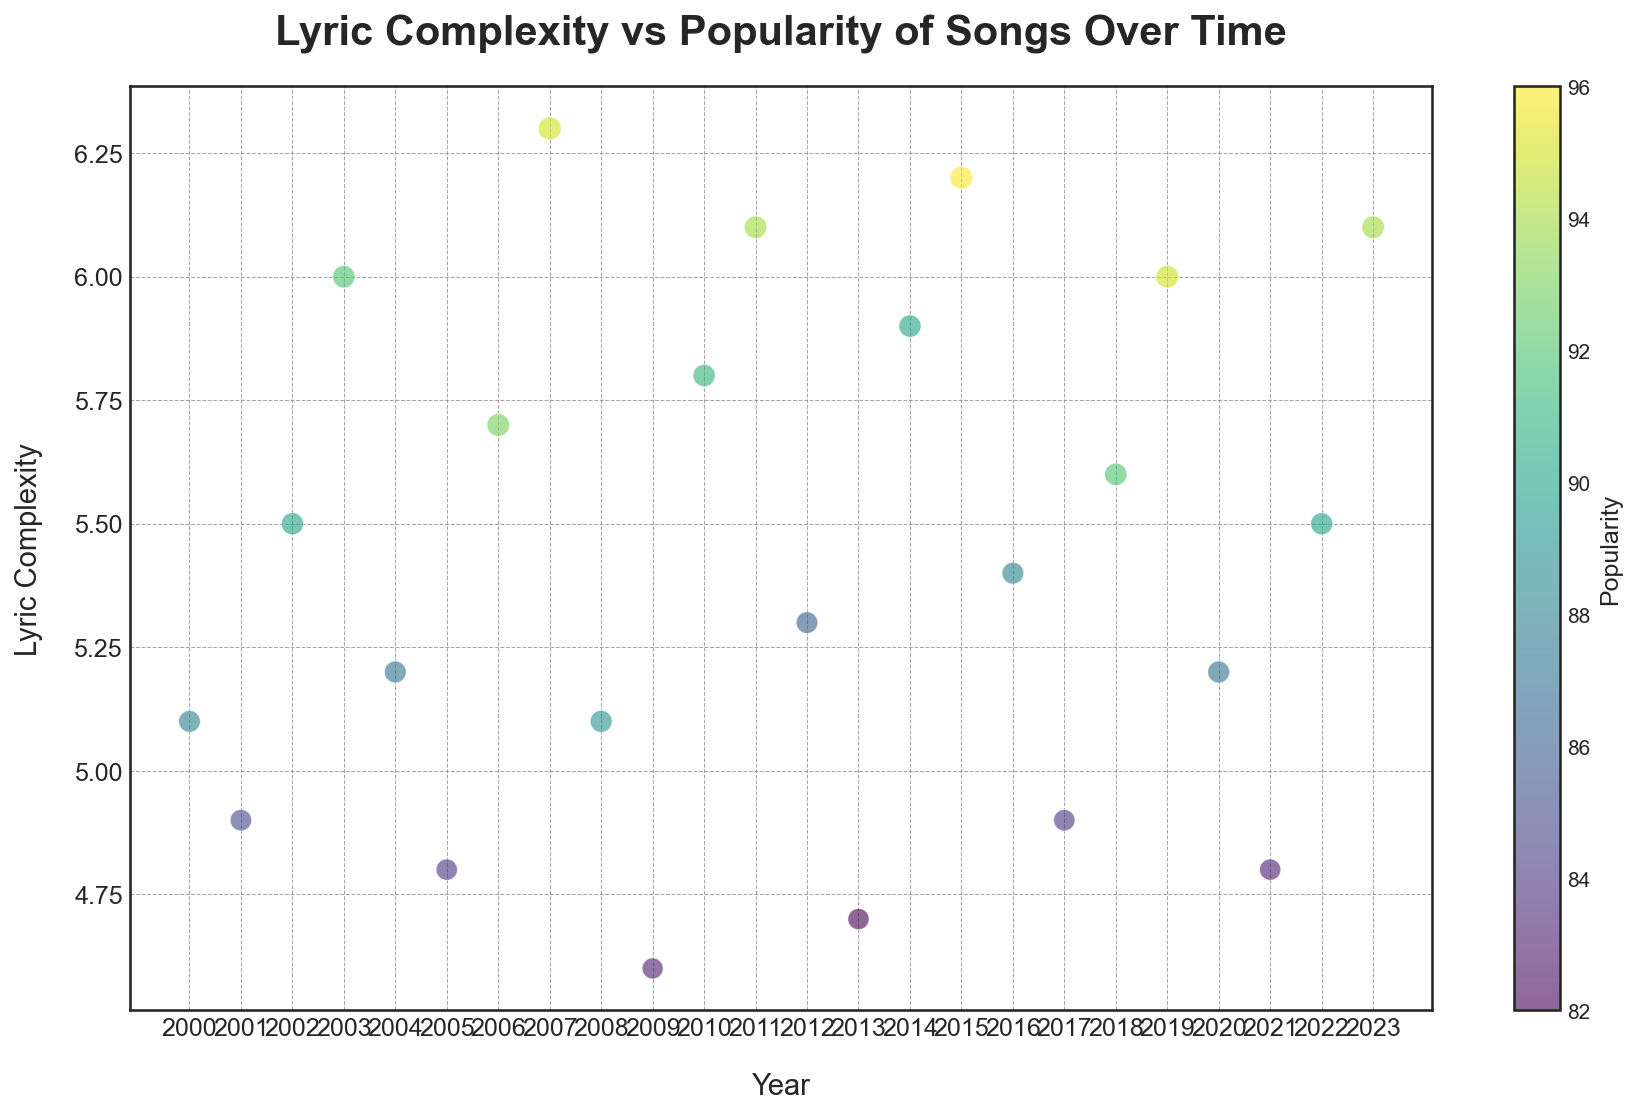What is the year with the highest lyric complexity? By examining the y-axis, which depicts lyric complexity, we can observe the highest point on the plot. The year at which this highest point occurs represents the year with the highest lyric complexity. This point is seen in the year 2007.
Answer: 2007 Which year has the highest popularity and how does its lyric complexity compare to the surrounding years? The color bar indicates that the highest popularity corresponds to a deep yellowish-green color. This color is most prominent in 2015. The lyric complexity for 2015 is about 6.2, higher than the complexity in 2014 and 2016.
Answer: 2015; higher complexity than surrounding years What trend do you observe in the lyric complexity from 2003 to 2007? By looking at the y-axis values of the points between 2003 and 2007, we notice an increasing trend. The points rise from 6.0 in 2003 to 6.3 in 2007, indicating a gradually increasing complexity.
Answer: Increasing trend Compare the lyric complexity and popularity of songs in 2006 and 2020. Which year has higher complexity and popularity? The plot shows that 2006 has a lyric complexity of 5.7 and popularity of 93, while 2020 has a lyric complexity of 5.2 and popularity of 87. Both lyric complexity and popularity are higher in 2006.
Answer: 2006 for both metrics During which years is the lyric complexity consistently above 6? By checking the y-axis for values above 6, we see peaks in 2007, 2011, 2015, 2019, and 2023. These years consistently maintain a lyric complexity above 6.
Answer: 2007, 2011, 2015, 2019, 2023 What's the average popularity value from 2010 to 2023? The popularity values from 2010 to 2023 are: 91, 94, 86, 82, 90, 96, 88, 84, 92, 95, 87, 83, 90, and 94. Adding these values gives 1262. Dividing by the number of years (14), the average popularity is 90.14.
Answer: 90.14 Which year between 2000 and 2023 has the lowest lyric complexity? The lowest point on the y-axis for lyric complexity is observed in 2009, where it reaches 4.6.
Answer: 2009 How does the complexity of lyrics in 2002 compare to the complexity of lyrics in 2022? Checking the y-axis for 2002 and 2022, we see that 2002 has a lyric complexity of 5.5, while 2022 also has a complexity of 5.5. This indicates equal complexity in these years.
Answer: Equal complexity Are there any years where the lyric complexity and popularity seem to be inversely related? A visual inspection of the plot reveals that in 2013, the lyric complexity is relatively low at 4.7, while the popularity is correspondingly lower at 82. Overviewing the plot, such years don't clearly show inverse relationships as complexity and popularity mostly seem positively related.
Answer: Not prominent Which year has the largest increase in lyric complexity compared to the previous year? Comparing the y-values year by year, the biggest increase in lyric complexity is observed between 2013 (4.7) and 2014 (5.9), indicating a sharp increase of 1.2.
Answer: 2014 